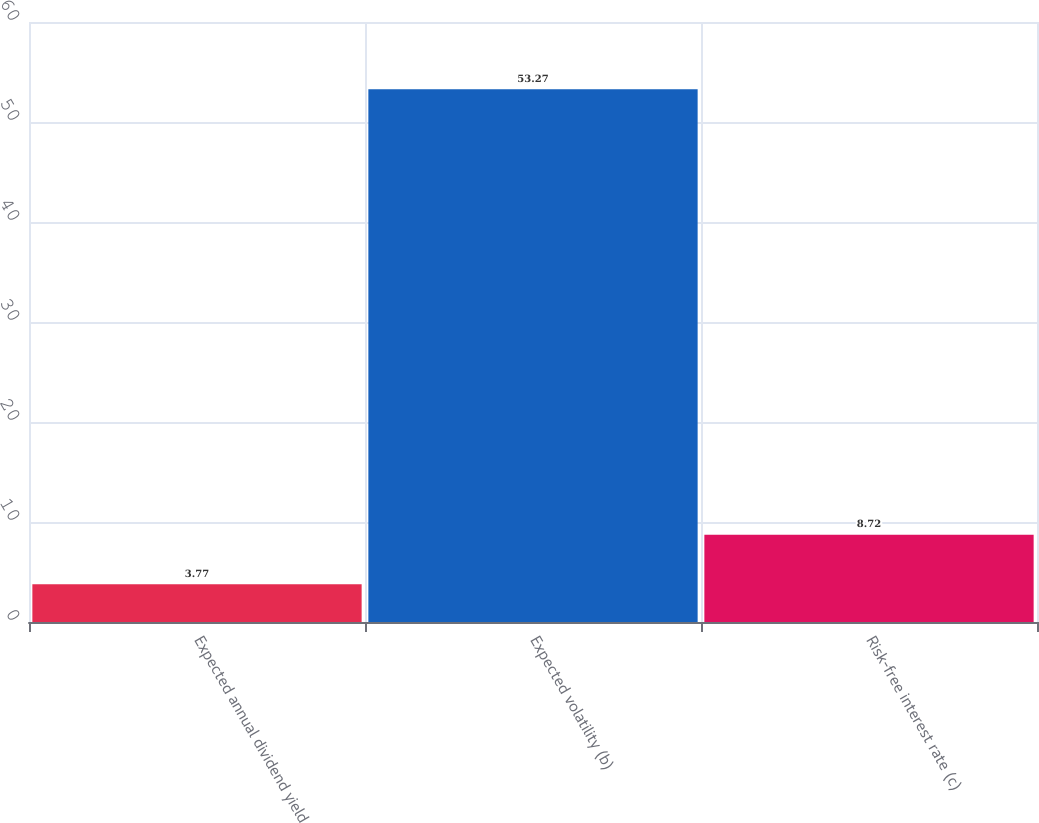<chart> <loc_0><loc_0><loc_500><loc_500><bar_chart><fcel>Expected annual dividend yield<fcel>Expected volatility (b)<fcel>Risk-free interest rate (c)<nl><fcel>3.77<fcel>53.27<fcel>8.72<nl></chart> 